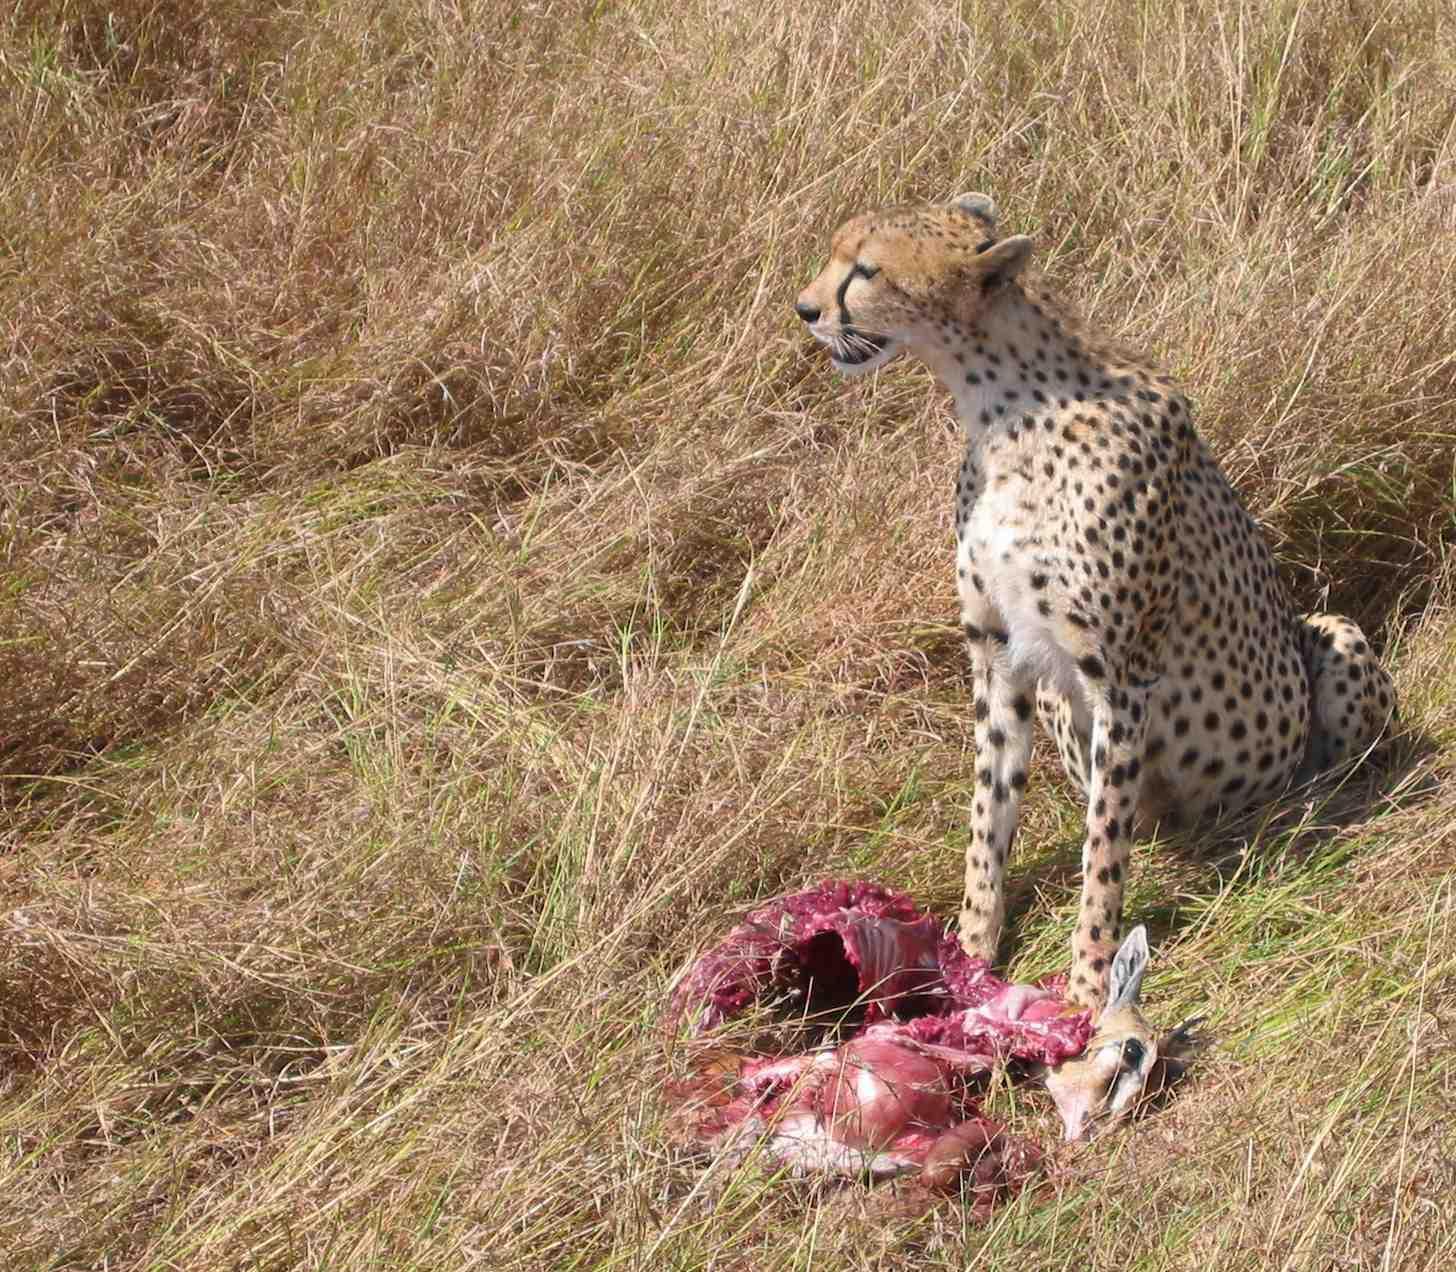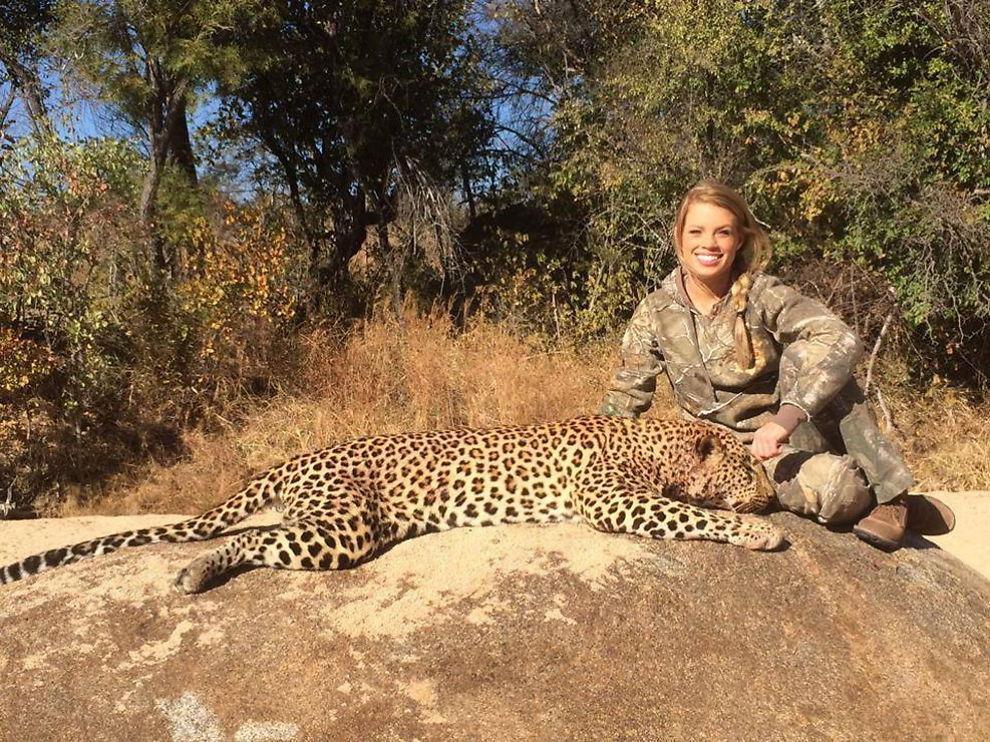The first image is the image on the left, the second image is the image on the right. Analyze the images presented: Is the assertion "All of the cheetahs appear to have young gazelles with them; this is how young cheetahs are taught to kill." valid? Answer yes or no. No. The first image is the image on the left, the second image is the image on the right. Considering the images on both sides, is "There are two baby cheetahs hunting a baby gazelle." valid? Answer yes or no. No. 